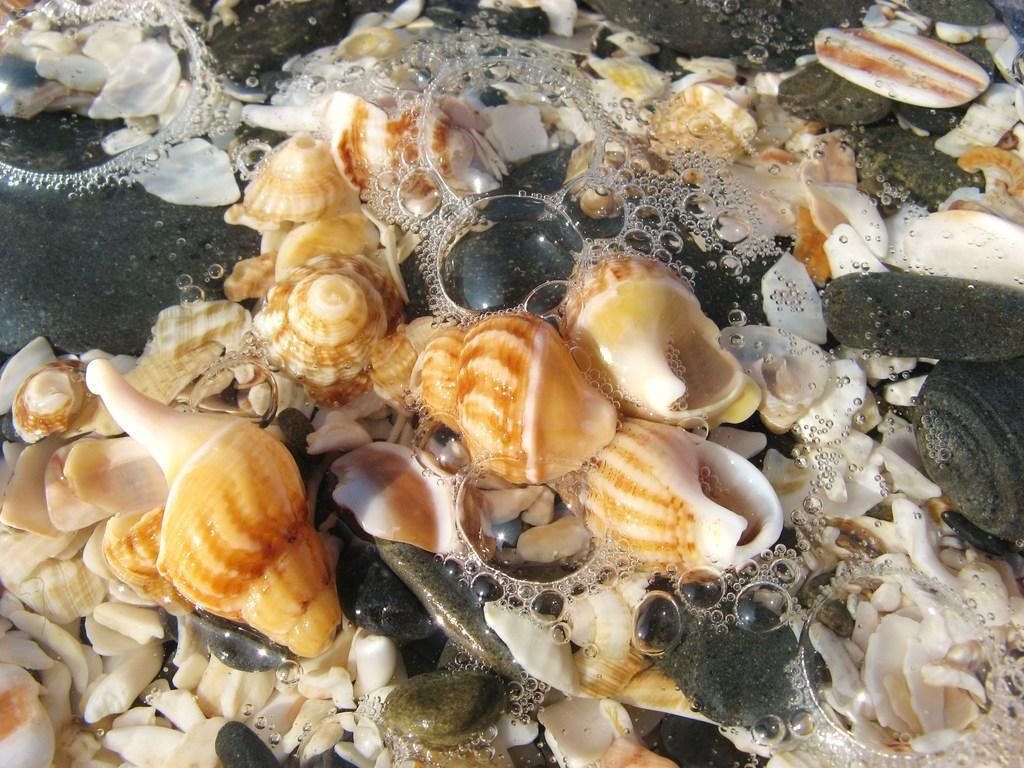What objects can be seen on the ground in the image? There are sea shells on the ground in the image. What else can be observed in the image besides the sea shells? There are water bubbles visible in the image. What is the weight of the slope in the image? There is no slope present in the image, and therefore no weight can be attributed to it. 